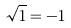<formula> <loc_0><loc_0><loc_500><loc_500>\sqrt { 1 } = - 1</formula> 